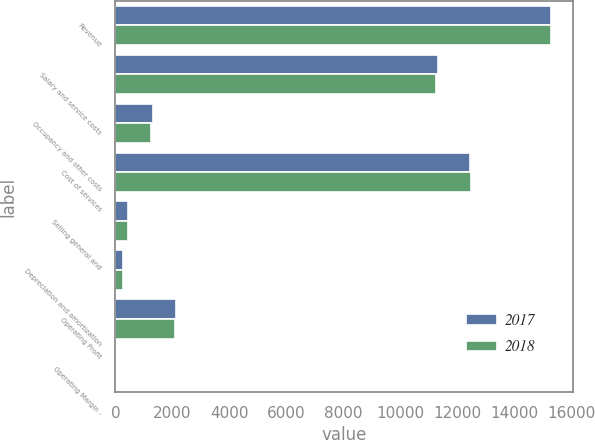Convert chart. <chart><loc_0><loc_0><loc_500><loc_500><stacked_bar_chart><ecel><fcel>Revenue<fcel>Salary and service costs<fcel>Occupancy and other costs<fcel>Cost of services<fcel>Selling general and<fcel>Depreciation and amortization<fcel>Operating Profit<fcel>Operating Margin -<nl><fcel>2017<fcel>15290.2<fcel>11306.1<fcel>1309.6<fcel>12437.3<fcel>455.4<fcel>264<fcel>2133.5<fcel>14<nl><fcel>2018<fcel>15273.6<fcel>11227.2<fcel>1240.8<fcel>12468<fcel>439.7<fcel>282.1<fcel>2083.8<fcel>13.6<nl></chart> 